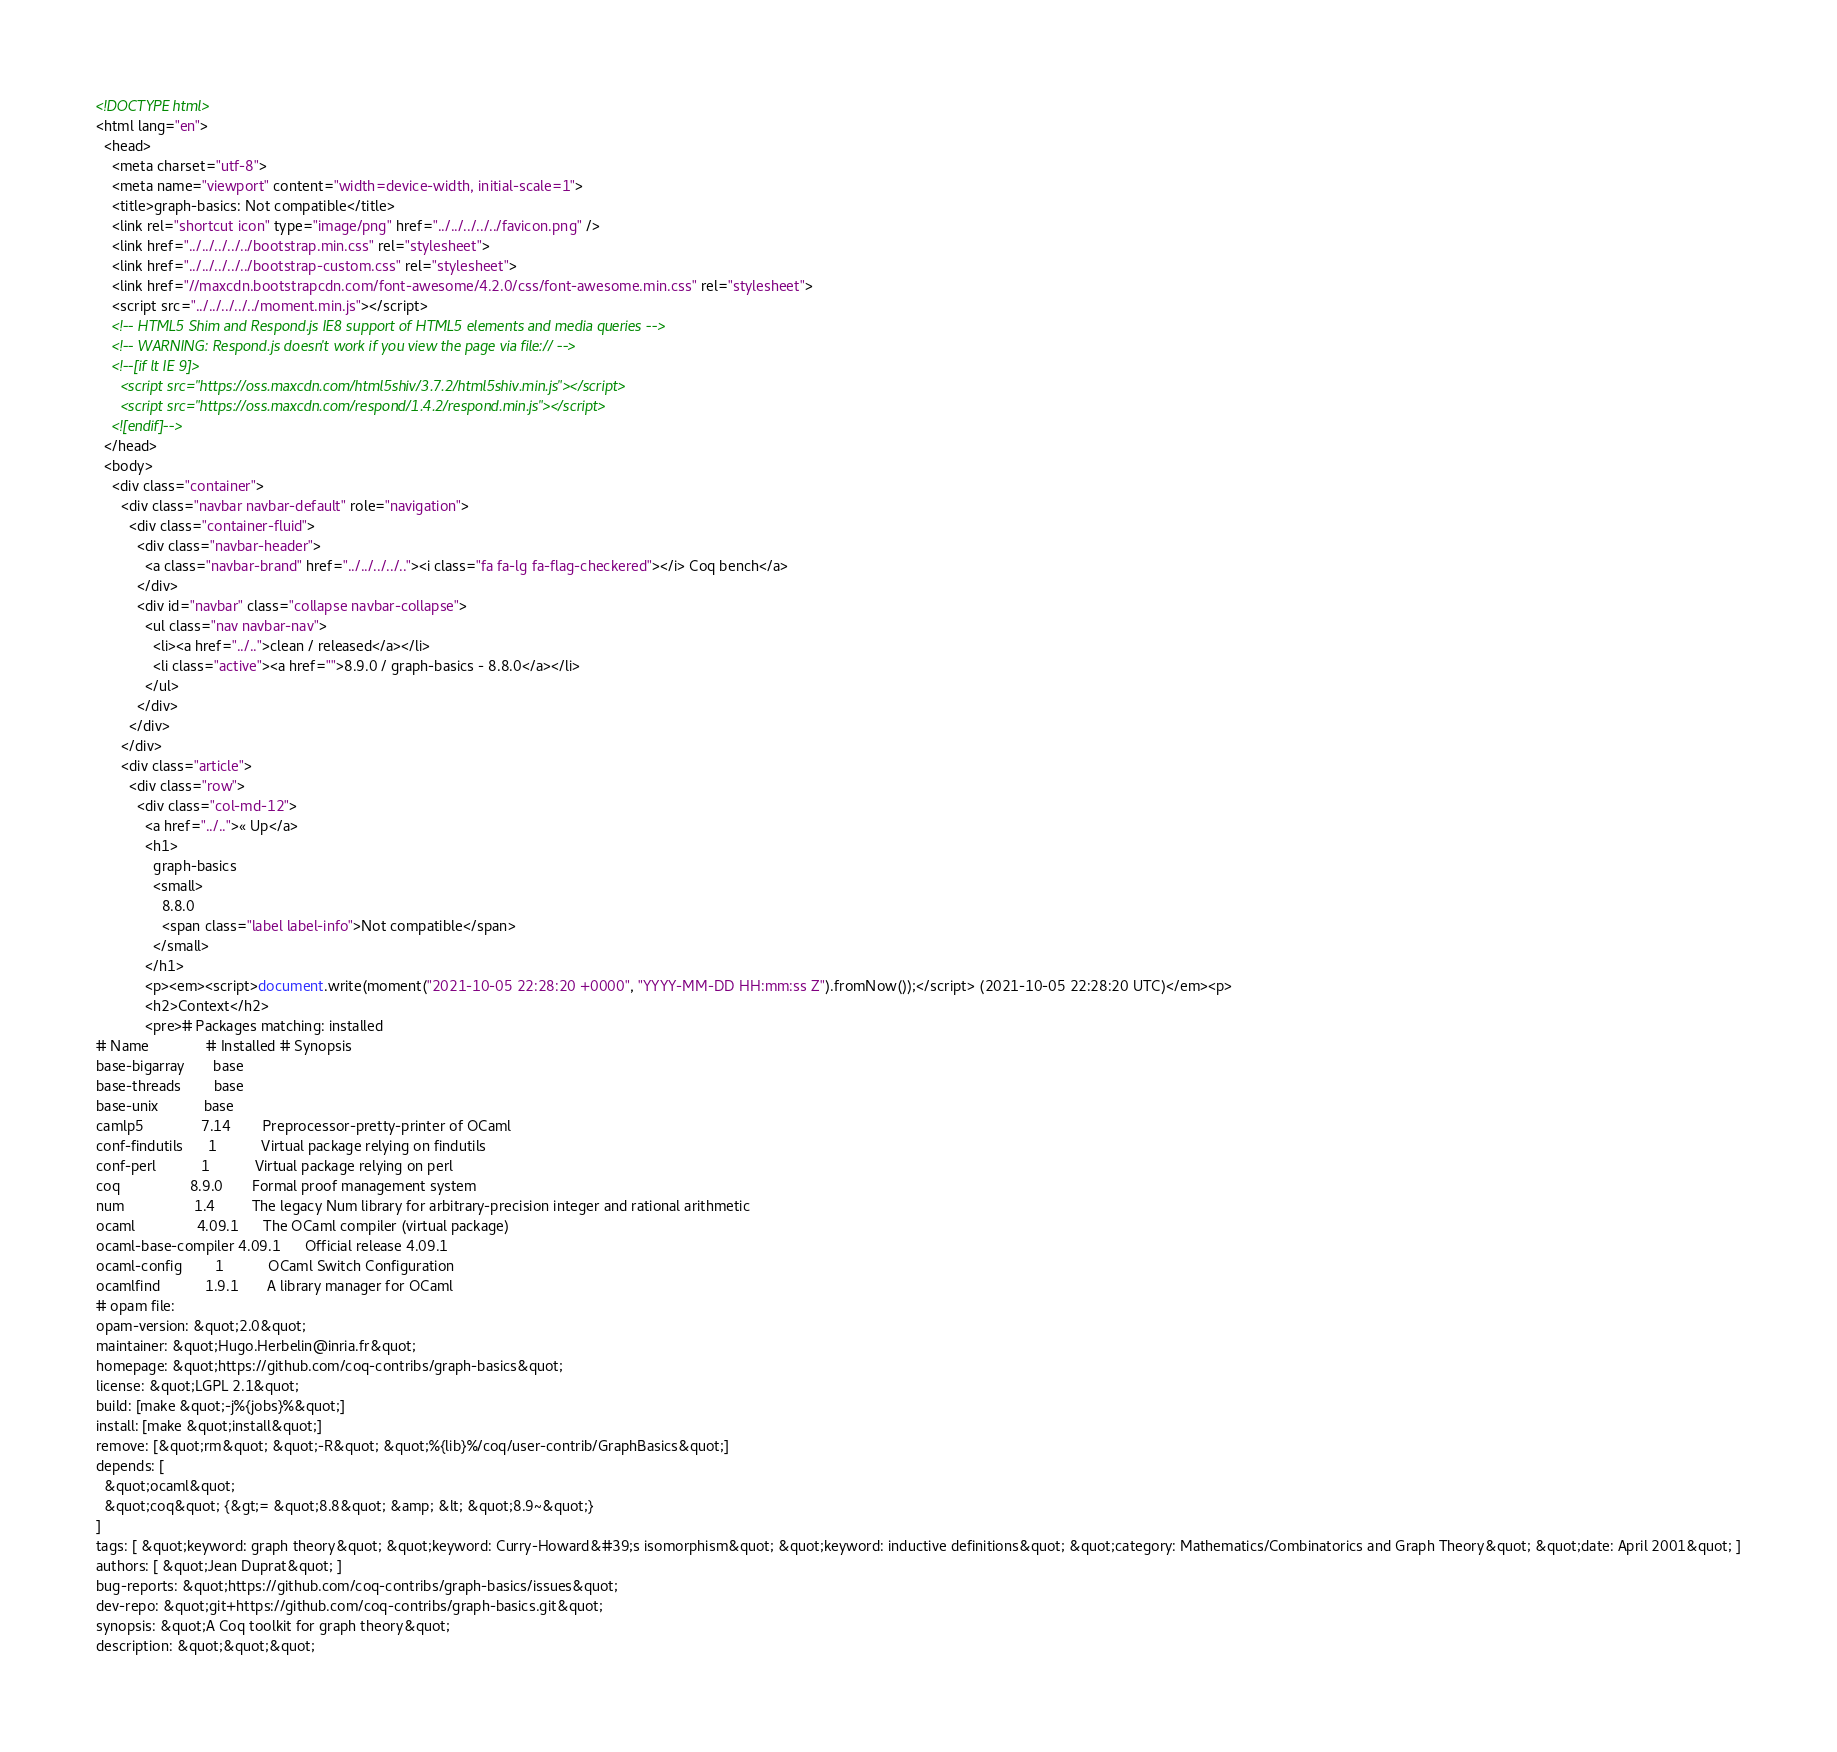<code> <loc_0><loc_0><loc_500><loc_500><_HTML_><!DOCTYPE html>
<html lang="en">
  <head>
    <meta charset="utf-8">
    <meta name="viewport" content="width=device-width, initial-scale=1">
    <title>graph-basics: Not compatible</title>
    <link rel="shortcut icon" type="image/png" href="../../../../../favicon.png" />
    <link href="../../../../../bootstrap.min.css" rel="stylesheet">
    <link href="../../../../../bootstrap-custom.css" rel="stylesheet">
    <link href="//maxcdn.bootstrapcdn.com/font-awesome/4.2.0/css/font-awesome.min.css" rel="stylesheet">
    <script src="../../../../../moment.min.js"></script>
    <!-- HTML5 Shim and Respond.js IE8 support of HTML5 elements and media queries -->
    <!-- WARNING: Respond.js doesn't work if you view the page via file:// -->
    <!--[if lt IE 9]>
      <script src="https://oss.maxcdn.com/html5shiv/3.7.2/html5shiv.min.js"></script>
      <script src="https://oss.maxcdn.com/respond/1.4.2/respond.min.js"></script>
    <![endif]-->
  </head>
  <body>
    <div class="container">
      <div class="navbar navbar-default" role="navigation">
        <div class="container-fluid">
          <div class="navbar-header">
            <a class="navbar-brand" href="../../../../.."><i class="fa fa-lg fa-flag-checkered"></i> Coq bench</a>
          </div>
          <div id="navbar" class="collapse navbar-collapse">
            <ul class="nav navbar-nav">
              <li><a href="../..">clean / released</a></li>
              <li class="active"><a href="">8.9.0 / graph-basics - 8.8.0</a></li>
            </ul>
          </div>
        </div>
      </div>
      <div class="article">
        <div class="row">
          <div class="col-md-12">
            <a href="../..">« Up</a>
            <h1>
              graph-basics
              <small>
                8.8.0
                <span class="label label-info">Not compatible</span>
              </small>
            </h1>
            <p><em><script>document.write(moment("2021-10-05 22:28:20 +0000", "YYYY-MM-DD HH:mm:ss Z").fromNow());</script> (2021-10-05 22:28:20 UTC)</em><p>
            <h2>Context</h2>
            <pre># Packages matching: installed
# Name              # Installed # Synopsis
base-bigarray       base
base-threads        base
base-unix           base
camlp5              7.14        Preprocessor-pretty-printer of OCaml
conf-findutils      1           Virtual package relying on findutils
conf-perl           1           Virtual package relying on perl
coq                 8.9.0       Formal proof management system
num                 1.4         The legacy Num library for arbitrary-precision integer and rational arithmetic
ocaml               4.09.1      The OCaml compiler (virtual package)
ocaml-base-compiler 4.09.1      Official release 4.09.1
ocaml-config        1           OCaml Switch Configuration
ocamlfind           1.9.1       A library manager for OCaml
# opam file:
opam-version: &quot;2.0&quot;
maintainer: &quot;Hugo.Herbelin@inria.fr&quot;
homepage: &quot;https://github.com/coq-contribs/graph-basics&quot;
license: &quot;LGPL 2.1&quot;
build: [make &quot;-j%{jobs}%&quot;]
install: [make &quot;install&quot;]
remove: [&quot;rm&quot; &quot;-R&quot; &quot;%{lib}%/coq/user-contrib/GraphBasics&quot;]
depends: [
  &quot;ocaml&quot;
  &quot;coq&quot; {&gt;= &quot;8.8&quot; &amp; &lt; &quot;8.9~&quot;}
]
tags: [ &quot;keyword: graph theory&quot; &quot;keyword: Curry-Howard&#39;s isomorphism&quot; &quot;keyword: inductive definitions&quot; &quot;category: Mathematics/Combinatorics and Graph Theory&quot; &quot;date: April 2001&quot; ]
authors: [ &quot;Jean Duprat&quot; ]
bug-reports: &quot;https://github.com/coq-contribs/graph-basics/issues&quot;
dev-repo: &quot;git+https://github.com/coq-contribs/graph-basics.git&quot;
synopsis: &quot;A Coq toolkit for graph theory&quot;
description: &quot;&quot;&quot;</code> 